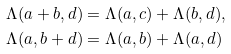Convert formula to latex. <formula><loc_0><loc_0><loc_500><loc_500>& \Lambda ( a + b , d ) = \Lambda ( a , c ) + \Lambda ( b , d ) , \\ & \Lambda ( a , b + d ) = \Lambda ( a , b ) + \Lambda ( a , d )</formula> 